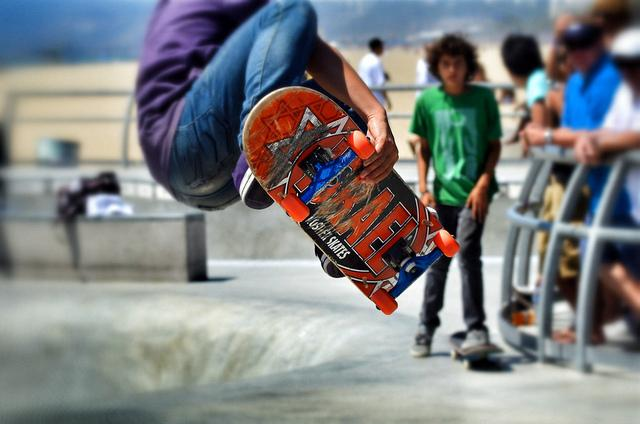Why is the boy wearing purple touching the bottom of the skateboard?

Choices:
A) throw it
B) clean it
C) performing tricks
D) massage it performing tricks 